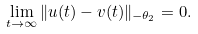<formula> <loc_0><loc_0><loc_500><loc_500>\lim _ { t \rightarrow \infty } \| u ( t ) - v ( t ) \| _ { - \theta _ { 2 } } = 0 .</formula> 